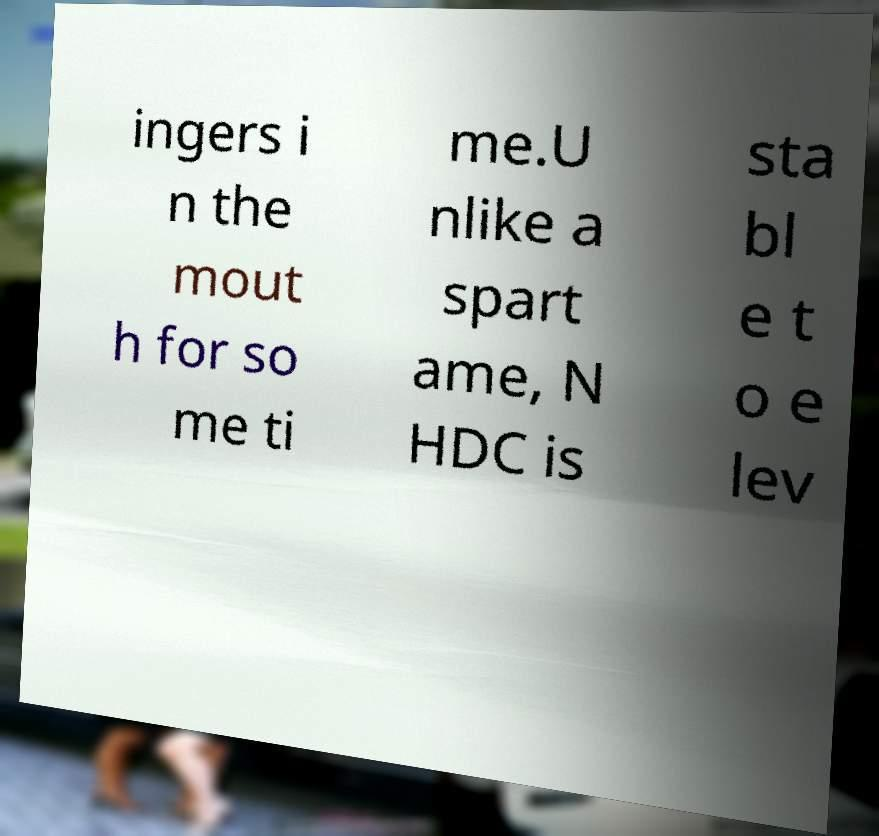Could you assist in decoding the text presented in this image and type it out clearly? ingers i n the mout h for so me ti me.U nlike a spart ame, N HDC is sta bl e t o e lev 